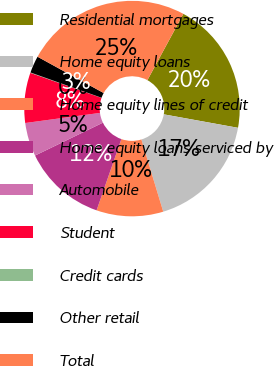Convert chart. <chart><loc_0><loc_0><loc_500><loc_500><pie_chart><fcel>Residential mortgages<fcel>Home equity loans<fcel>Home equity lines of credit<fcel>Home equity loans serviced by<fcel>Automobile<fcel>Student<fcel>Credit cards<fcel>Other retail<fcel>Total<nl><fcel>19.95%<fcel>17.46%<fcel>10.01%<fcel>12.49%<fcel>5.04%<fcel>7.52%<fcel>0.06%<fcel>2.55%<fcel>24.92%<nl></chart> 